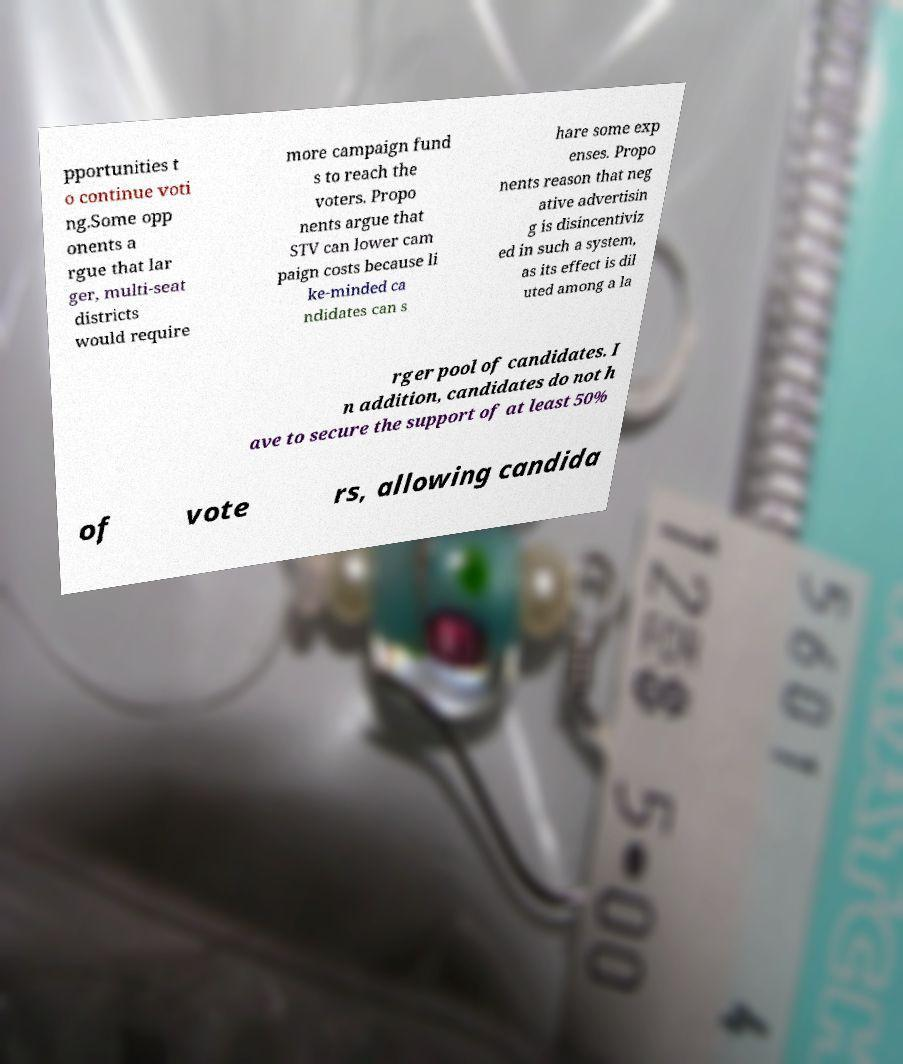I need the written content from this picture converted into text. Can you do that? pportunities t o continue voti ng.Some opp onents a rgue that lar ger, multi-seat districts would require more campaign fund s to reach the voters. Propo nents argue that STV can lower cam paign costs because li ke-minded ca ndidates can s hare some exp enses. Propo nents reason that neg ative advertisin g is disincentiviz ed in such a system, as its effect is dil uted among a la rger pool of candidates. I n addition, candidates do not h ave to secure the support of at least 50% of vote rs, allowing candida 